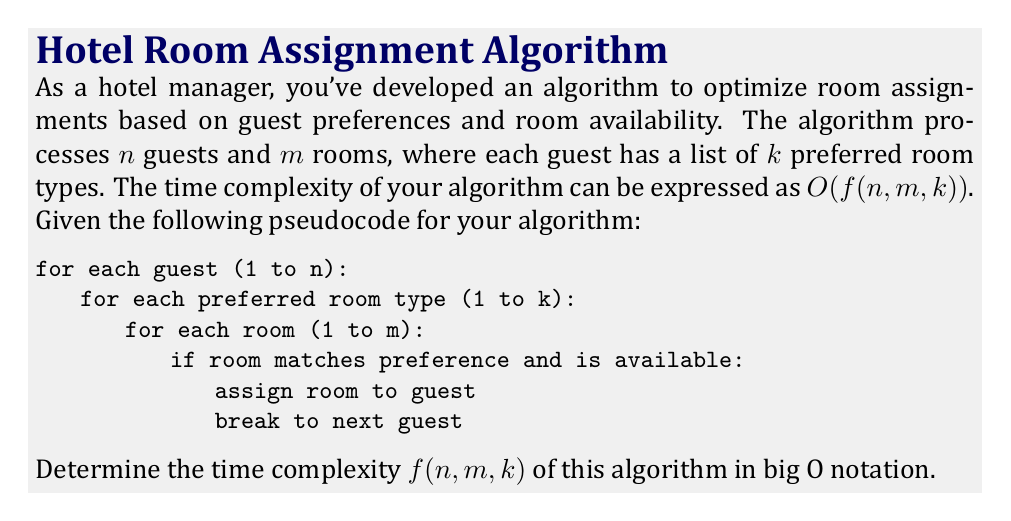Give your solution to this math problem. To determine the time complexity of the given algorithm, we need to analyze the nested loops and their operations:

1. The outermost loop iterates through all guests, which runs $n$ times.

2. For each guest, we iterate through their preferred room types, which runs $k$ times.

3. For each preferred room type, we check all rooms, which runs $m$ times.

4. The innermost operation (checking if a room matches the preference and is available) is considered a constant time operation.

Given this structure, we can break down the time complexity analysis:

1. The innermost loop runs $m$ times for each iteration of the middle loop.
2. The middle loop runs $k$ times for each iteration of the outer loop.
3. The outer loop runs $n$ times.

Therefore, in the worst-case scenario (where no suitable room is found until the last iteration), the total number of operations is:

$$ n \times k \times m $$

This gives us a time complexity of $O(nkm)$.

It's worth noting that in practice, the algorithm might terminate earlier for some guests if a suitable room is found before checking all preferences or all rooms. However, for big O notation, we consider the worst-case scenario.
Answer: $O(nkm)$ 